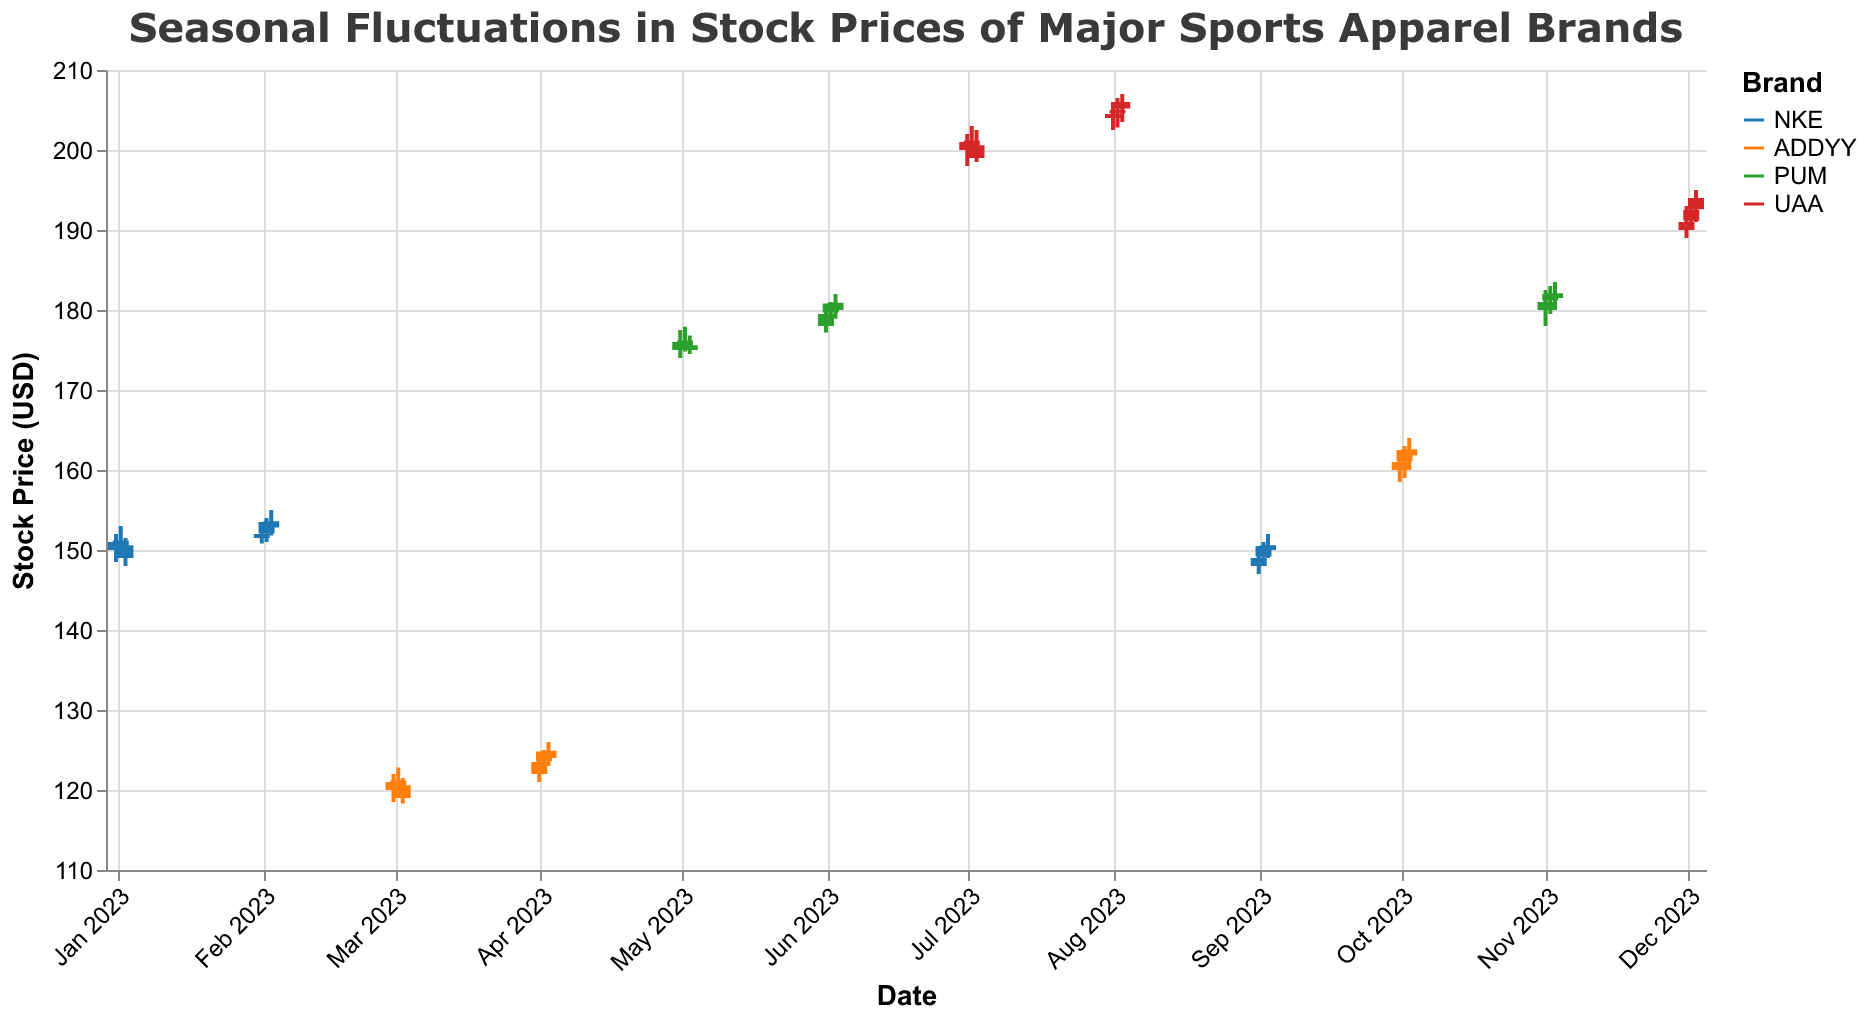What is the average closing price of NKE in January 2023? To calculate the average closing price, add up all the closing prices for NKE in January and divide by the number of days. So, (151.00 + 150.50 + 149.00) / 3 = 450.50 / 3 = 150.17
Answer: 150.17 Which brand had the highest closing price in July 2023? The closing prices in July for UAA are 201.00, 200.50, and 199.00. The highest of these is 201.00
Answer: UAA Was there any month where PUM's closing price consistently increased over three consecutive days? By examining the monthly data for PUM, we see that in June, the closing prices were 179.50, 180.80, and 180.00. The prices increase from 179.50 to 180.80 but then slightly decrease to 180.00. Thus, there's no consistent increase over three consecutive days in one month.
Answer: No Which ticker saw the biggest variance in its closing prices within a single month, and what was the corresponding month? First, calculate the range (difference between the highest and lowest closing price) for each ticker in each month. For UAA in July, the difference is 201.00 - 199.00 = 2. For UAA in December, the difference is 194.00 - 191.00 = 3. For PUM in May, it's 176.00 - 175.00 = 1, in June, it's 180.80 - 179.50 = 1.3, and in November, it's 182.00 - 181.00 = 1. For ADDYY in March, it's 121.00 - 119.00 = 2, in April, it's 124.80 - 123.50 = 1.3, and in October, it's 162.50 - 161.00 = 1.5. For NKE in January, it's 151.00 - 149.00 = 2, in February, it's 153.50 - 152.00 = 1.5, and in September, it's 150.50 - 149.00 = 1.5. The biggest variance observed is for UAA in December with a range of 3.
Answer: UAA, December Did the trading volume for any ticker reach its peak in the same month when its closing price was at its highest? For this, we identify the month(s) with the highest closing prices first, and then check if those months also have the highest trading volumes. For UAA, the highest closing price is 206.00 in August, with a trading volume of 5300000, highest volume also in August. For ADDYY, the highest closing price is 162.50 in October, trading volume of 4400000, highest volume was 4300000 in April. For PUM, the highest closing price is 180.80 in June, with a trading volume of 4900000, highest volume also in June. For NKE, the highest closing price is 153.50 in February, with a trading volume of 3800000, highest volume was 3450000 in January. Thus, only UAA and PUM reach their highest trading volumes in the same months as their highest closing prices.
Answer: UAA and PUM 